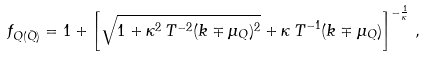Convert formula to latex. <formula><loc_0><loc_0><loc_500><loc_500>f _ { Q ( \bar { Q } ) } = 1 + \left [ \sqrt { 1 + \kappa ^ { 2 } \, T ^ { - 2 } ( k \mp \mu _ { Q } ) ^ { 2 } } + \kappa \, T ^ { - 1 } ( k \mp \mu _ { Q } ) \right ] ^ { - \frac { 1 } { \kappa } } \, ,</formula> 